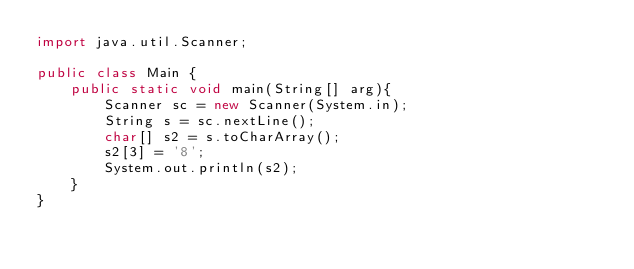<code> <loc_0><loc_0><loc_500><loc_500><_Java_>import java.util.Scanner;

public class Main {
    public static void main(String[] arg){
        Scanner sc = new Scanner(System.in);
        String s = sc.nextLine();
        char[] s2 = s.toCharArray();
        s2[3] = '8';
        System.out.println(s2);
    }
}</code> 